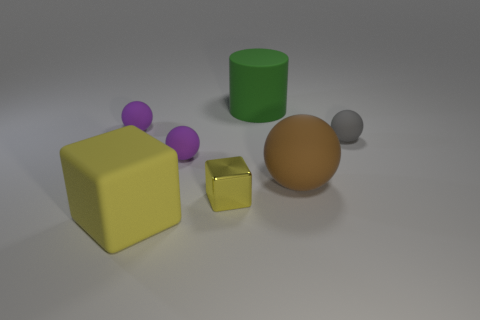What material is the gray sphere that is the same size as the yellow metal thing?
Ensure brevity in your answer.  Rubber. How many other things are the same material as the tiny yellow cube?
Give a very brief answer. 0. The rubber object that is behind the big brown object and in front of the gray matte sphere is what color?
Give a very brief answer. Purple. What number of objects are either large matte things in front of the tiny block or large metallic cylinders?
Provide a succinct answer. 1. What number of other things are the same color as the matte cube?
Your answer should be compact. 1. Are there an equal number of gray balls that are to the left of the large brown matte thing and brown matte things?
Make the answer very short. No. There is a purple object that is in front of the small rubber object to the right of the cylinder; how many purple spheres are to the left of it?
Offer a very short reply. 1. Do the green matte cylinder and the purple ball left of the matte cube have the same size?
Make the answer very short. No. What number of tiny metallic blocks are there?
Your answer should be compact. 1. There is a yellow object that is in front of the small yellow metal thing; does it have the same size as the cylinder behind the tiny yellow shiny cube?
Offer a very short reply. Yes. 